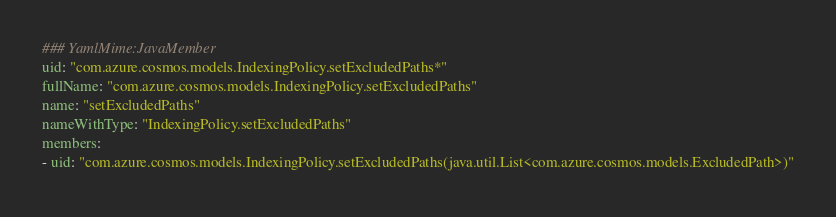Convert code to text. <code><loc_0><loc_0><loc_500><loc_500><_YAML_>### YamlMime:JavaMember
uid: "com.azure.cosmos.models.IndexingPolicy.setExcludedPaths*"
fullName: "com.azure.cosmos.models.IndexingPolicy.setExcludedPaths"
name: "setExcludedPaths"
nameWithType: "IndexingPolicy.setExcludedPaths"
members:
- uid: "com.azure.cosmos.models.IndexingPolicy.setExcludedPaths(java.util.List<com.azure.cosmos.models.ExcludedPath>)"</code> 